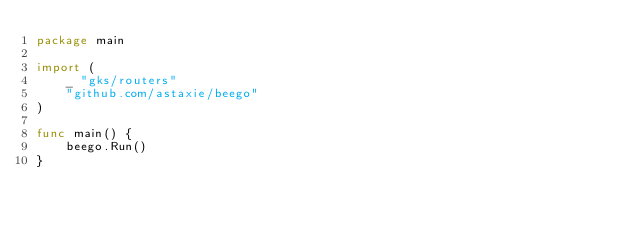<code> <loc_0><loc_0><loc_500><loc_500><_Go_>package main

import (
    _ "gks/routers"
    "github.com/astaxie/beego"
)

func main() {
    beego.Run()
}
</code> 